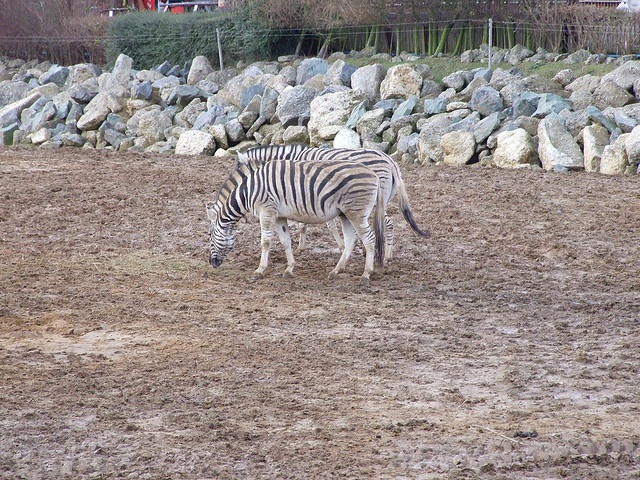Describe the objects in this image and their specific colors. I can see zebra in gray, darkgray, and lightgray tones and zebra in gray, lightgray, and darkgray tones in this image. 